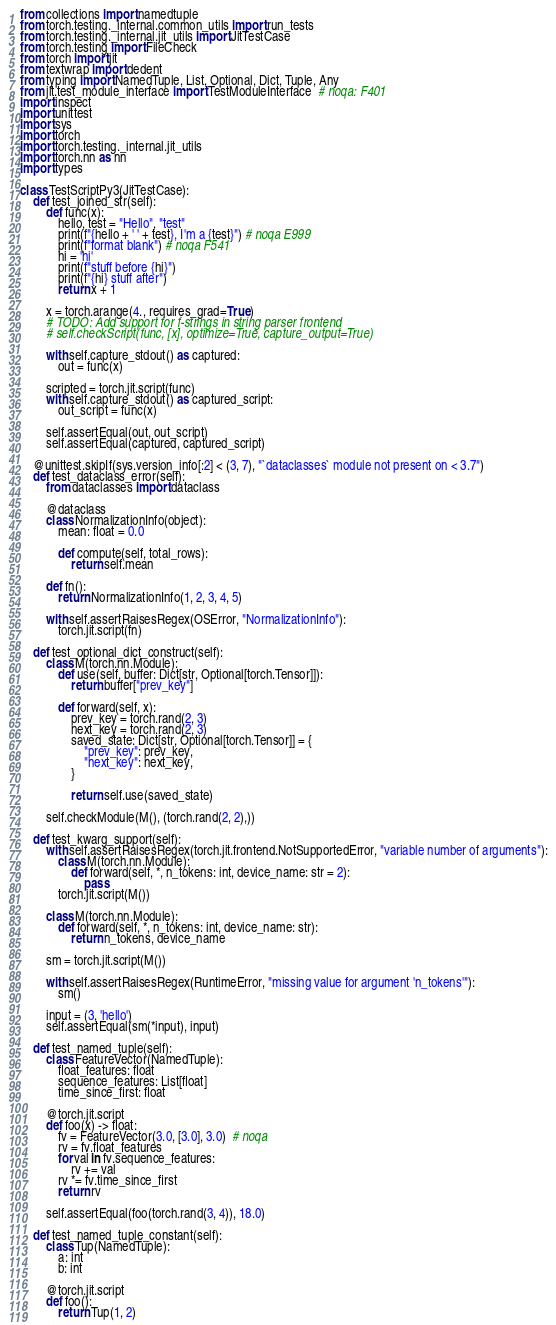<code> <loc_0><loc_0><loc_500><loc_500><_Python_>from collections import namedtuple
from torch.testing._internal.common_utils import run_tests
from torch.testing._internal.jit_utils import JitTestCase
from torch.testing import FileCheck
from torch import jit
from textwrap import dedent
from typing import NamedTuple, List, Optional, Dict, Tuple, Any
from jit.test_module_interface import TestModuleInterface  # noqa: F401
import inspect
import unittest
import sys
import torch
import torch.testing._internal.jit_utils
import torch.nn as nn
import types

class TestScriptPy3(JitTestCase):
    def test_joined_str(self):
        def func(x):
            hello, test = "Hello", "test"
            print(f"{hello + ' ' + test}, I'm a {test}") # noqa E999
            print(f"format blank") # noqa F541
            hi = 'hi'
            print(f"stuff before {hi}")
            print(f"{hi} stuff after")
            return x + 1

        x = torch.arange(4., requires_grad=True)
        # TODO: Add support for f-strings in string parser frontend
        # self.checkScript(func, [x], optimize=True, capture_output=True)

        with self.capture_stdout() as captured:
            out = func(x)

        scripted = torch.jit.script(func)
        with self.capture_stdout() as captured_script:
            out_script = func(x)

        self.assertEqual(out, out_script)
        self.assertEqual(captured, captured_script)

    @unittest.skipIf(sys.version_info[:2] < (3, 7), "`dataclasses` module not present on < 3.7")
    def test_dataclass_error(self):
        from dataclasses import dataclass

        @dataclass
        class NormalizationInfo(object):
            mean: float = 0.0

            def compute(self, total_rows):
                return self.mean

        def fn():
            return NormalizationInfo(1, 2, 3, 4, 5)

        with self.assertRaisesRegex(OSError, "NormalizationInfo"):
            torch.jit.script(fn)

    def test_optional_dict_construct(self):
        class M(torch.nn.Module):
            def use(self, buffer: Dict[str, Optional[torch.Tensor]]):
                return buffer["prev_key"]

            def forward(self, x):
                prev_key = torch.rand(2, 3)
                next_key = torch.rand(2, 3)
                saved_state: Dict[str, Optional[torch.Tensor]] = {
                    "prev_key": prev_key,
                    "next_key": next_key,
                }

                return self.use(saved_state)

        self.checkModule(M(), (torch.rand(2, 2),))

    def test_kwarg_support(self):
        with self.assertRaisesRegex(torch.jit.frontend.NotSupportedError, "variable number of arguments"):
            class M(torch.nn.Module):
                def forward(self, *, n_tokens: int, device_name: str = 2):
                    pass
            torch.jit.script(M())

        class M(torch.nn.Module):
            def forward(self, *, n_tokens: int, device_name: str):
                return n_tokens, device_name

        sm = torch.jit.script(M())

        with self.assertRaisesRegex(RuntimeError, "missing value for argument 'n_tokens'"):
            sm()

        input = (3, 'hello')
        self.assertEqual(sm(*input), input)

    def test_named_tuple(self):
        class FeatureVector(NamedTuple):
            float_features: float
            sequence_features: List[float]
            time_since_first: float

        @torch.jit.script
        def foo(x) -> float:
            fv = FeatureVector(3.0, [3.0], 3.0)  # noqa
            rv = fv.float_features
            for val in fv.sequence_features:
                rv += val
            rv *= fv.time_since_first
            return rv

        self.assertEqual(foo(torch.rand(3, 4)), 18.0)

    def test_named_tuple_constant(self):
        class Tup(NamedTuple):
            a: int
            b: int

        @torch.jit.script
        def foo():
            return Tup(1, 2)
</code> 